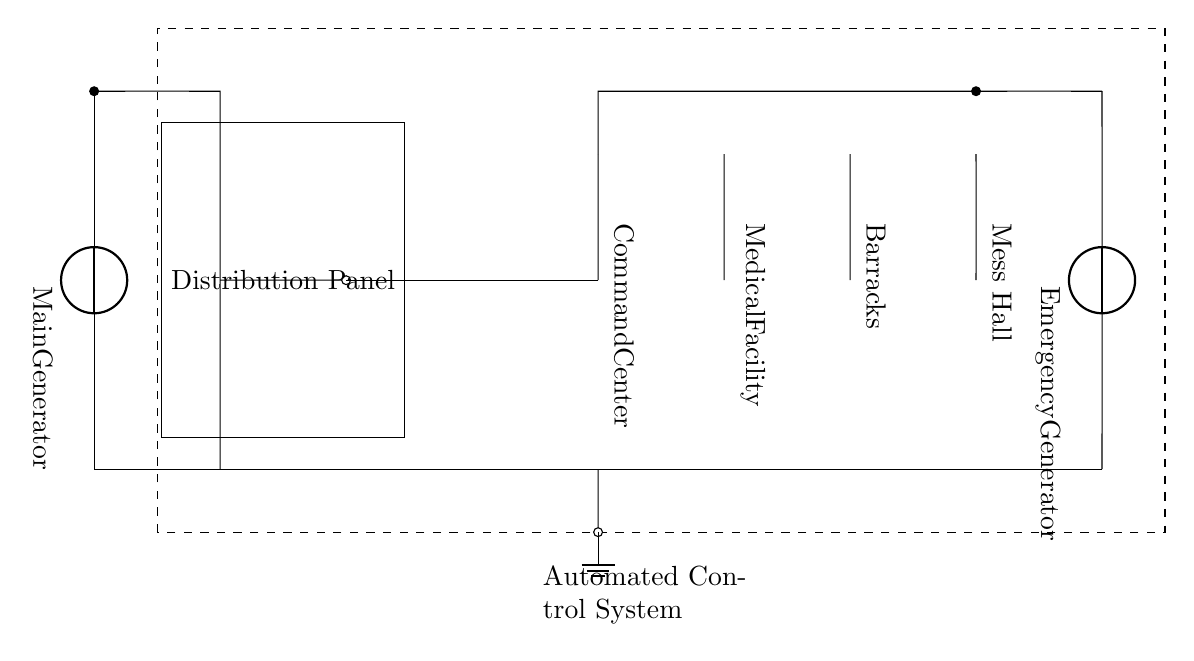What is the main power source of this circuit? The circuit indicates that the main power source is a generator, specifically labeled as "Main Generator." This is identified at the start of the circuit diagram on the left side.
Answer: Main Generator What kind of system is present for control? The control system is indicated as an "Automated Control System" in a dashed rectangle within the circuit diagram. It shows the presence of control technology to manage the distribution of power.
Answer: Automated Control System How many load centers are connected to the transformer? The circuit shows four distinct load centers connected to the transformer, specifically labeled as "Command Center," "Medical Facility," "Barracks," and "Mess Hall." Each is a unique point where power is supplied.
Answer: Four What is the purpose of the emergency generator in this circuit? The emergency generator is an additional power source, ensuring continuity of power supply to the system in case the main generator fails. This is essential for military operations where power reliability is crucial.
Answer: Backup power Where do the ground connections lead in this circuit? The ground connection is established at a point indicated at the base, implying a common ground return for electrical safety and stability. It connects the main components of the power distribution.
Answer: Ground connection What component is used to step down voltage in this circuit? The circuit includes a transformer specifically designed to adjust voltage levels for distribution to the various load centers. A transformer is indicated between the distribution panel and the load centers.
Answer: Transformer How is power distributed from the main generator? Power is distributed from the main generator through a distribution panel which then connects to the transformer, followed by individual connections to each load center, ensuring regulated power delivery.
Answer: Via Distribution Panel 